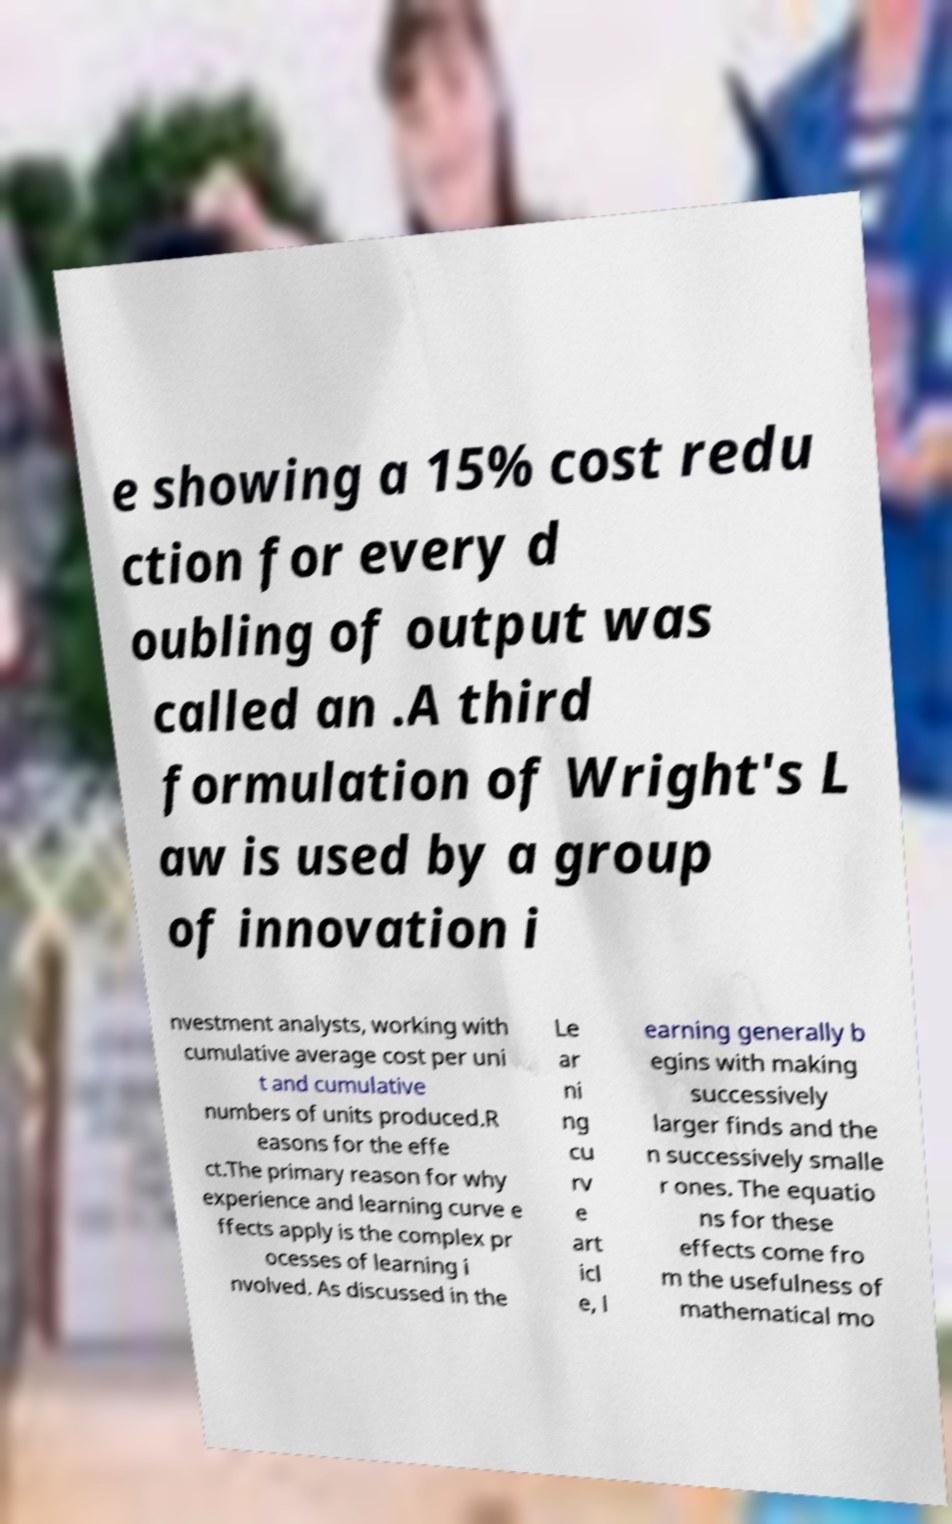Could you extract and type out the text from this image? e showing a 15% cost redu ction for every d oubling of output was called an .A third formulation of Wright's L aw is used by a group of innovation i nvestment analysts, working with cumulative average cost per uni t and cumulative numbers of units produced.R easons for the effe ct.The primary reason for why experience and learning curve e ffects apply is the complex pr ocesses of learning i nvolved. As discussed in the Le ar ni ng cu rv e art icl e, l earning generally b egins with making successively larger finds and the n successively smalle r ones. The equatio ns for these effects come fro m the usefulness of mathematical mo 